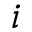Convert formula to latex. <formula><loc_0><loc_0><loc_500><loc_500>i</formula> 